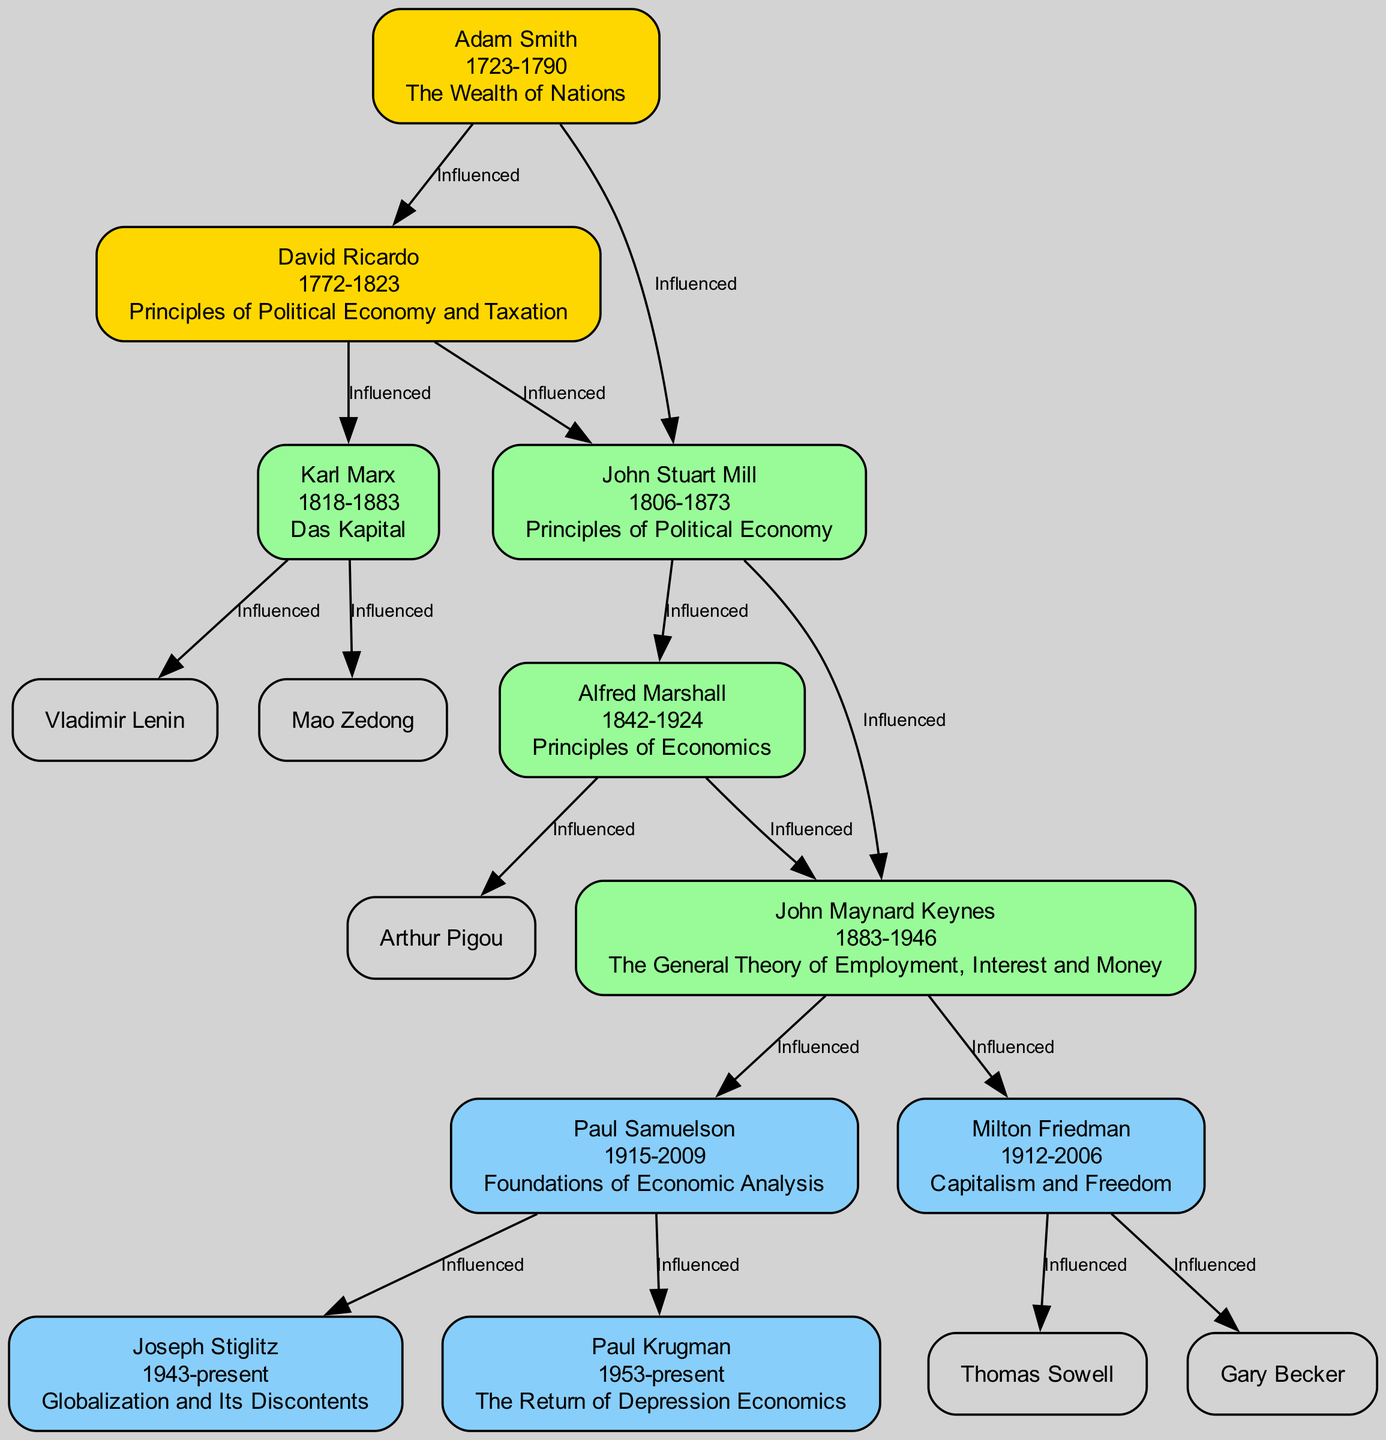What is the key work of Adam Smith? Adam Smith's key work is "The Wealth of Nations," as indicated next to his node in the diagram.
Answer: The Wealth of Nations Who influenced John Stuart Mill? The diagram shows that John Stuart Mill was influenced by both Adam Smith and David Ricardo, as labeled on the edges leading to his node.
Answer: Adam Smith, David Ricardo Which economist is associated with the theory of "Comparative Advantage"? According to the diagram, David Ricardo is associated with the theory of "Comparative Advantage," as listed under his theories.
Answer: David Ricardo How many economists are influenced by John Maynard Keynes? By examining the diagram, we can see that John Maynard Keynes influenced two economists: Paul Samuelson and Milton Friedman, meaning he has two edges pointing from his node.
Answer: 2 Which economist lived the longest? The diagram shows the lifespans of each economist, and Karl Marx lived from 1818 to 1883, which totals 65 years, making him one of the longer-living economists. However, to determine the longest-lived economist, we compare the lifespans, and Paul Samuelson, who lived from 1915 to 2009, has the longest lifespan of 94 years.
Answer: Paul Samuelson What is the dominant influence of Paul Samuelson? The diagram indicates that Paul Samuelson is influenced by John Maynard Keynes, as shown by the edge leading from Keynes to Samuelson.
Answer: John Maynard Keynes Which theory is associated with Joseph Stiglitz? Joseph Stiglitz is associated with the theories of "Information Asymmetry" and "Market Failure," which are listed under his theories in the diagram.
Answer: Information Asymmetry, Market Failure How many theories are attributed to Alfred Marshall? The diagram lists two theories associated with Alfred Marshall: "Price Elasticity" and "Supply and Demand." Thus, by simply counting from the list, we find that there are two theories.
Answer: 2 Who influenced Karl Marx? According to the diagram, the only economist that influenced Karl Marx is David Ricardo, as indicated by the edge between Ricardo and Marx.
Answer: David Ricardo 